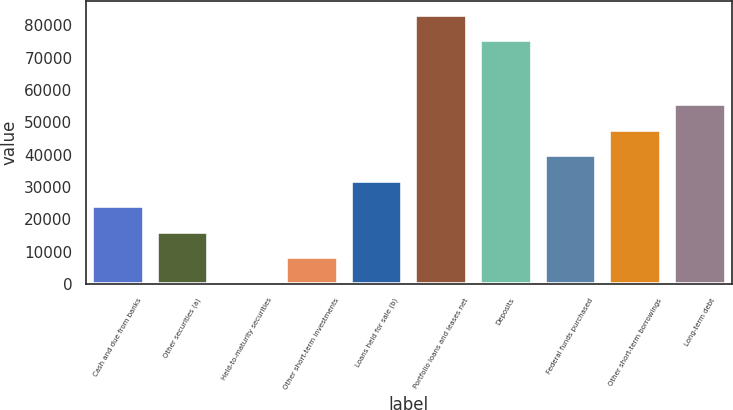Convert chart to OTSL. <chart><loc_0><loc_0><loc_500><loc_500><bar_chart><fcel>Cash and due from banks<fcel>Other securities (a)<fcel>Held-to-maturity securities<fcel>Other short-term investments<fcel>Loans held for sale (b)<fcel>Portfolio loans and leases net<fcel>Deposits<fcel>Federal funds purchased<fcel>Other short-term borrowings<fcel>Long-term debt<nl><fcel>24043.3<fcel>16147.2<fcel>355<fcel>8251.1<fcel>31939.4<fcel>83341.1<fcel>75445<fcel>39835.5<fcel>47731.6<fcel>55627.7<nl></chart> 